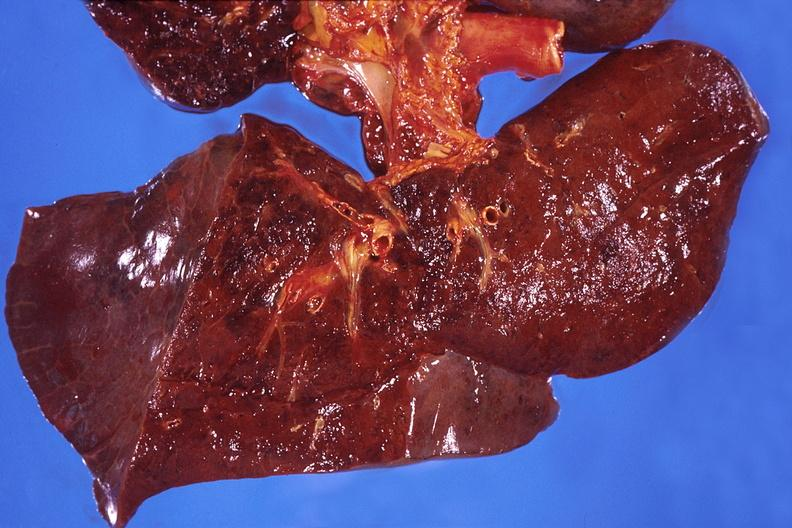does this image show lung, hemorrhagic bronchopneumonia, wilson 's disease?
Answer the question using a single word or phrase. Yes 